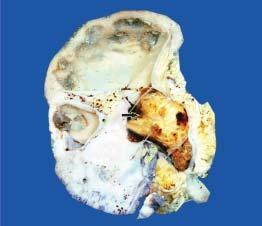does the pelvis of the kidney contain a single, large, soft yellow white stone taking the contour of the pelvi-calyceal system arrow?
Answer the question using a single word or phrase. Yes 